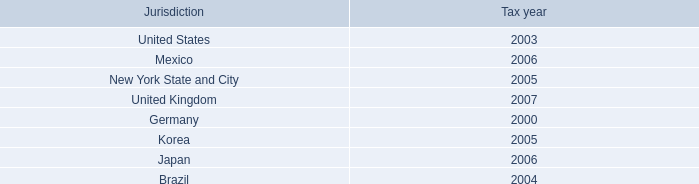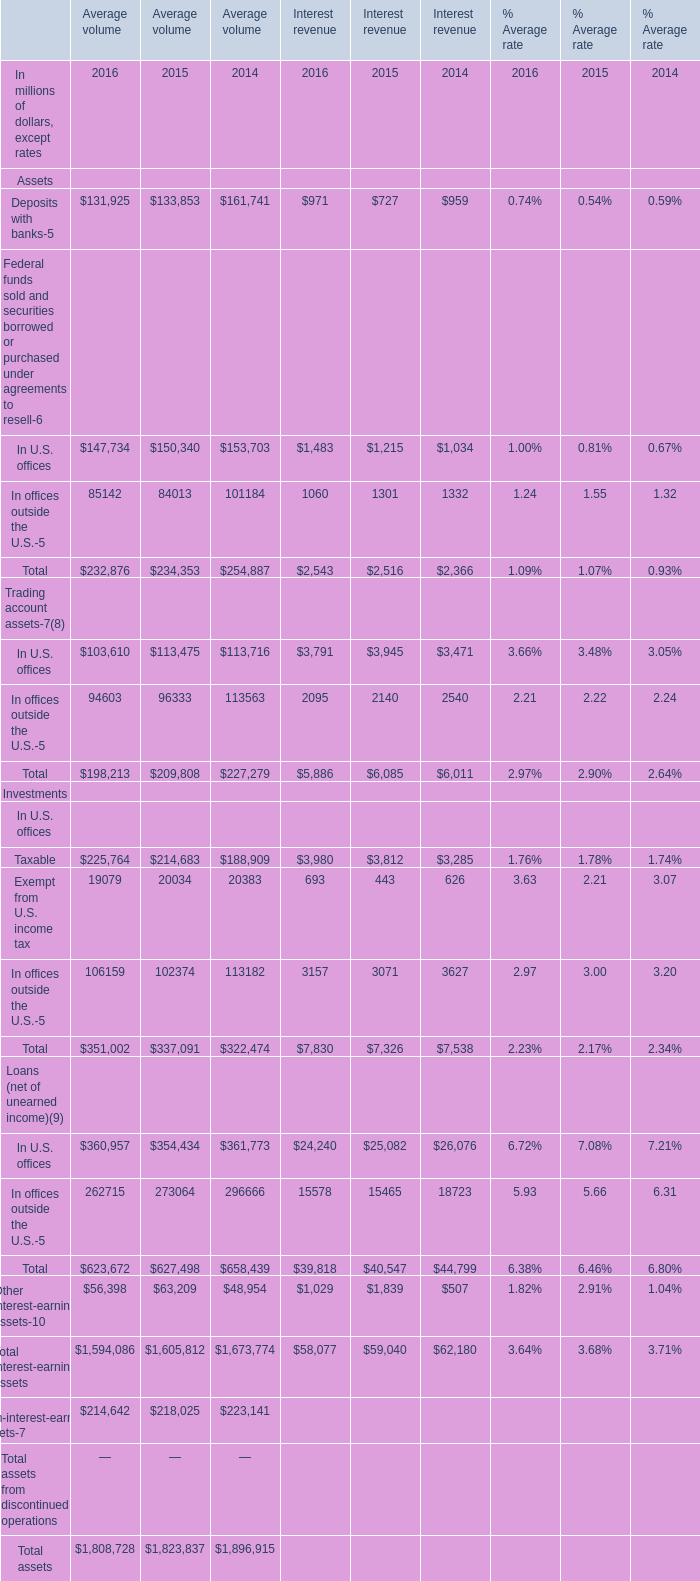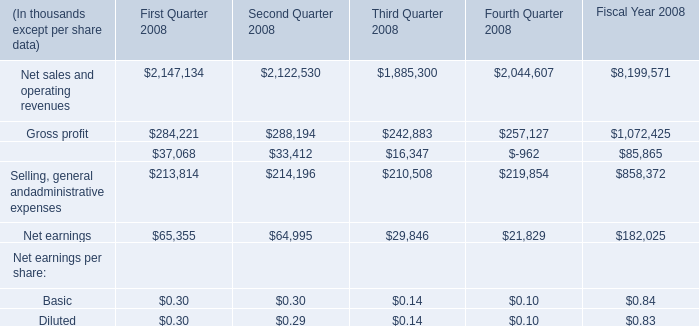What is the total amount of Selling, general andadministrative expenses of Second Quarter 2008, Deposits with banks of Average volume 2016, and In U.S. offices Federal funds sold and securities borrowed or purchased under agreements to resell of Interest revenue 2016 ? 
Computations: ((214196.0 + 131925.0) + 1483.0)
Answer: 347604.0. 